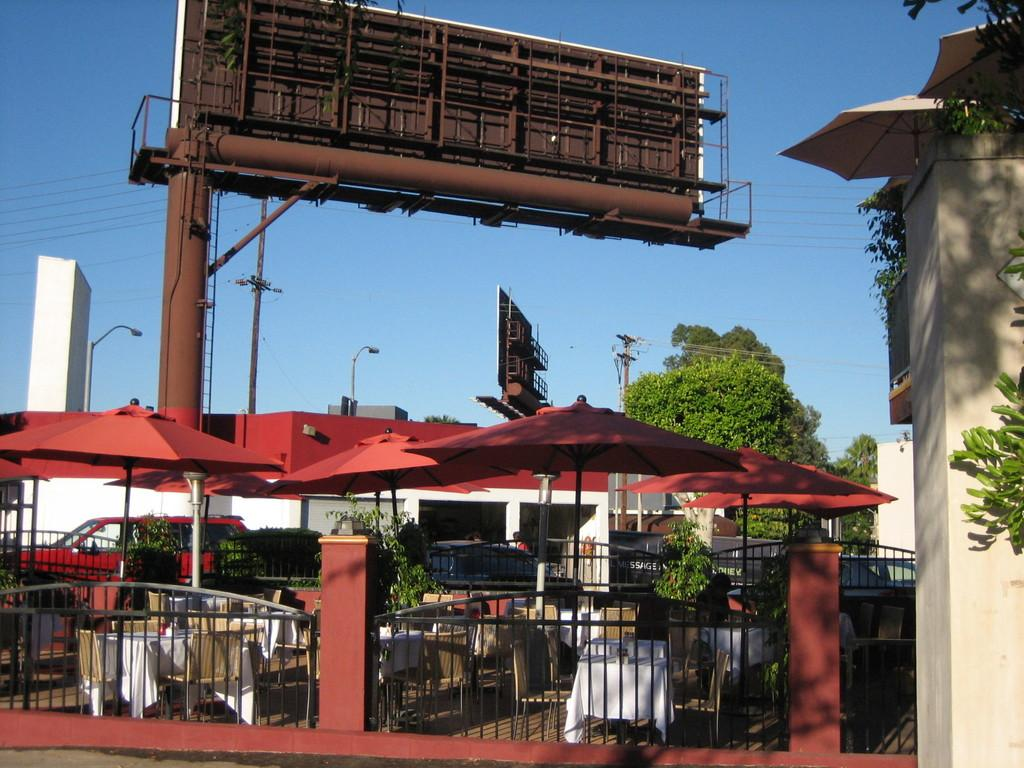What type of structures can be seen in the image? There are hoardings, poles, trees, buildings, and fencing visible in the image. What type of objects are present in the image? There are vehicles, tables, and chairs visible in the image. What is the color of the sky in the image? The sky is blue in the image. What else can be seen in the image? There are wires visible in the image. What type of beef is being served at the table in the image? There is no beef present in the image; the image only shows tables and chairs. What channel is the body of water in the image? There is no body of water present in the image; it only shows wires, buildings, and other structures. 